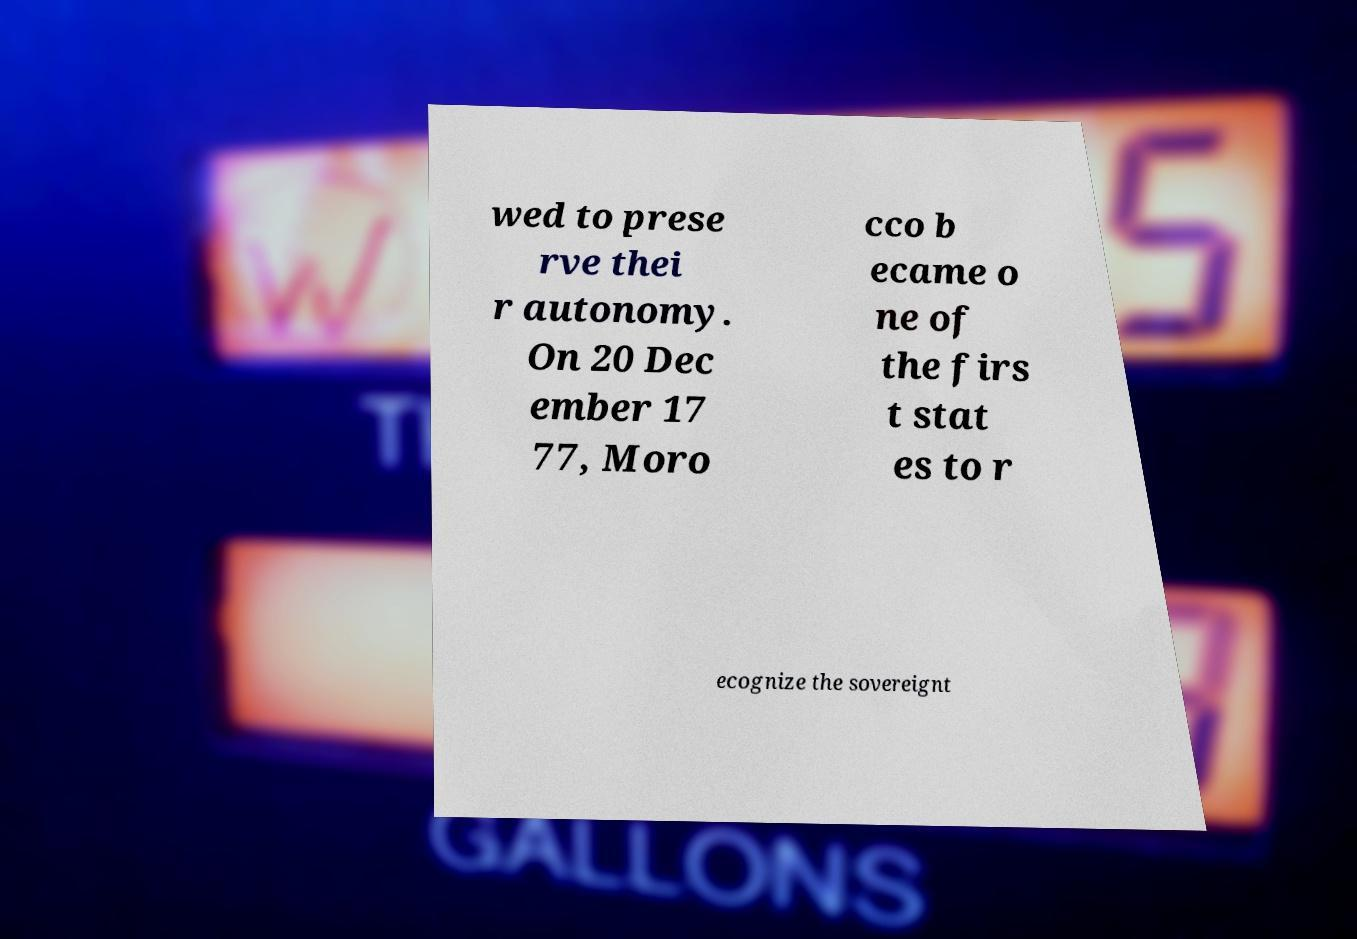Please identify and transcribe the text found in this image. wed to prese rve thei r autonomy. On 20 Dec ember 17 77, Moro cco b ecame o ne of the firs t stat es to r ecognize the sovereignt 